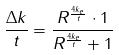Convert formula to latex. <formula><loc_0><loc_0><loc_500><loc_500>\frac { \Delta k } { t } = \frac { R ^ { \frac { 4 k _ { e } } { t } } \cdot 1 } { R ^ { \frac { 4 k _ { e } } { t } } + 1 }</formula> 